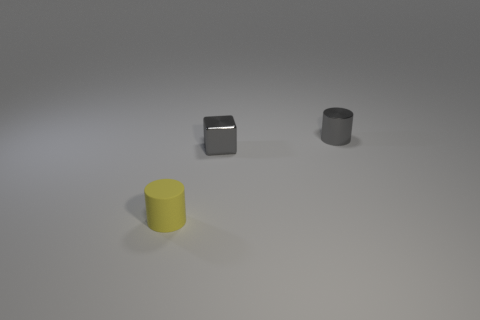Are there any other things that have the same material as the yellow cylinder?
Offer a terse response. No. There is a yellow matte object; how many yellow objects are in front of it?
Provide a short and direct response. 0. What is the size of the metallic object that is the same shape as the rubber thing?
Your answer should be very brief. Small. There is a thing that is to the left of the metallic cylinder and behind the tiny rubber object; what size is it?
Your answer should be compact. Small. Do the small metallic cylinder and the cylinder that is in front of the small metal cube have the same color?
Make the answer very short. No. How many green things are rubber cubes or small matte objects?
Make the answer very short. 0. What number of other things are the same shape as the tiny yellow thing?
Keep it short and to the point. 1. What color is the small cylinder that is behind the yellow rubber cylinder?
Make the answer very short. Gray. Is the block made of the same material as the gray cylinder?
Keep it short and to the point. Yes. What number of objects are gray metallic objects or small cylinders right of the metallic cube?
Provide a short and direct response. 2. 